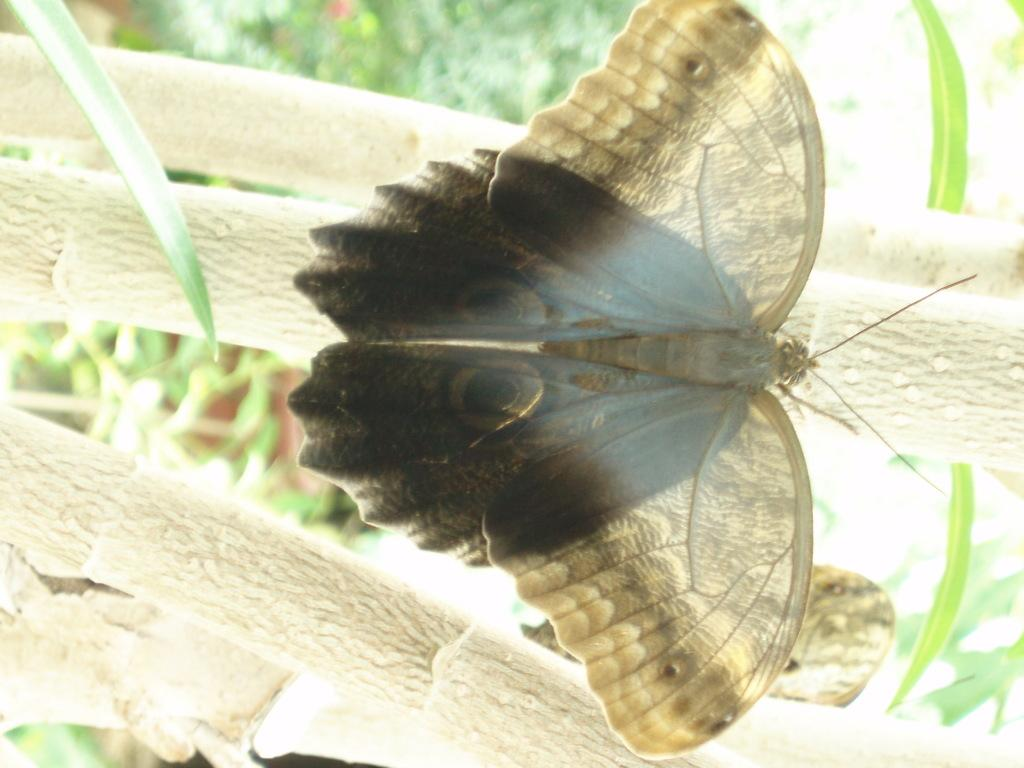What is the main subject of the image? There is a butterfly in the image. Where is the butterfly located? The butterfly is on a branch. What else can be seen in the image besides the butterfly? There are leaves in the image. Can you describe the background of the image? The background of the image is blurred. What type of volleyball game is being played in the background of the image? There is no volleyball game present in the image; it features a butterfly on a branch with leaves in the foreground and a blurred background. 